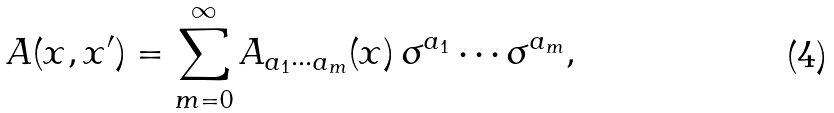<formula> <loc_0><loc_0><loc_500><loc_500>A ( x , x ^ { \prime } ) = \sum _ { m = 0 } ^ { \infty } A _ { a _ { 1 } \cdots a _ { m } } ( x ) \, \sigma ^ { a _ { 1 } } \cdots \sigma ^ { a _ { m } } ,</formula> 